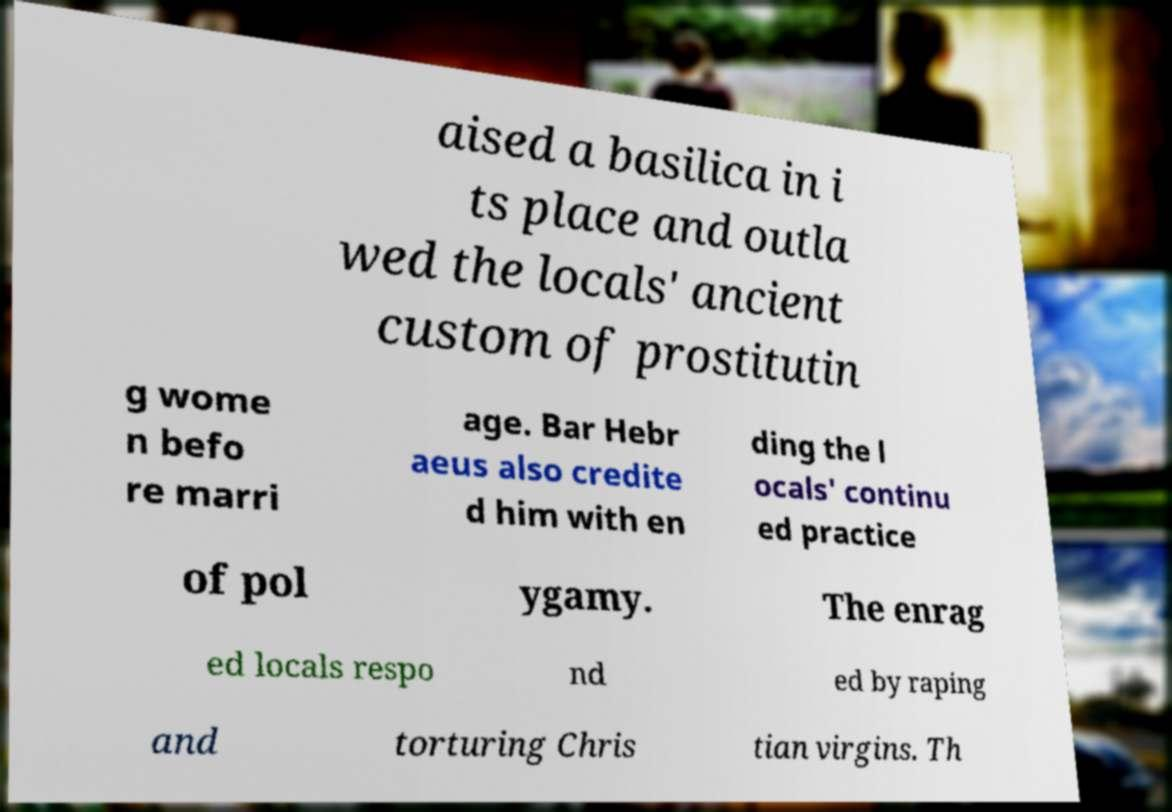There's text embedded in this image that I need extracted. Can you transcribe it verbatim? aised a basilica in i ts place and outla wed the locals' ancient custom of prostitutin g wome n befo re marri age. Bar Hebr aeus also credite d him with en ding the l ocals' continu ed practice of pol ygamy. The enrag ed locals respo nd ed by raping and torturing Chris tian virgins. Th 